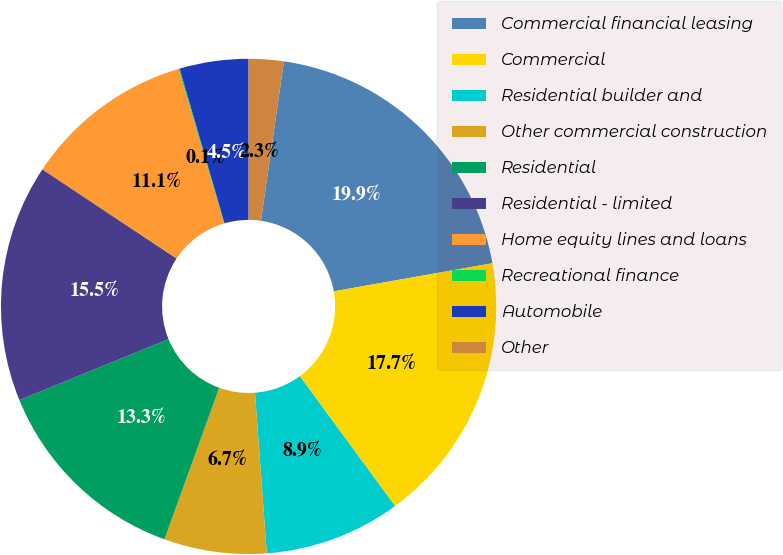Convert chart. <chart><loc_0><loc_0><loc_500><loc_500><pie_chart><fcel>Commercial financial leasing<fcel>Commercial<fcel>Residential builder and<fcel>Other commercial construction<fcel>Residential<fcel>Residential - limited<fcel>Home equity lines and loans<fcel>Recreational finance<fcel>Automobile<fcel>Other<nl><fcel>19.93%<fcel>17.72%<fcel>8.9%<fcel>6.69%<fcel>13.31%<fcel>15.51%<fcel>11.1%<fcel>0.07%<fcel>4.49%<fcel>2.28%<nl></chart> 